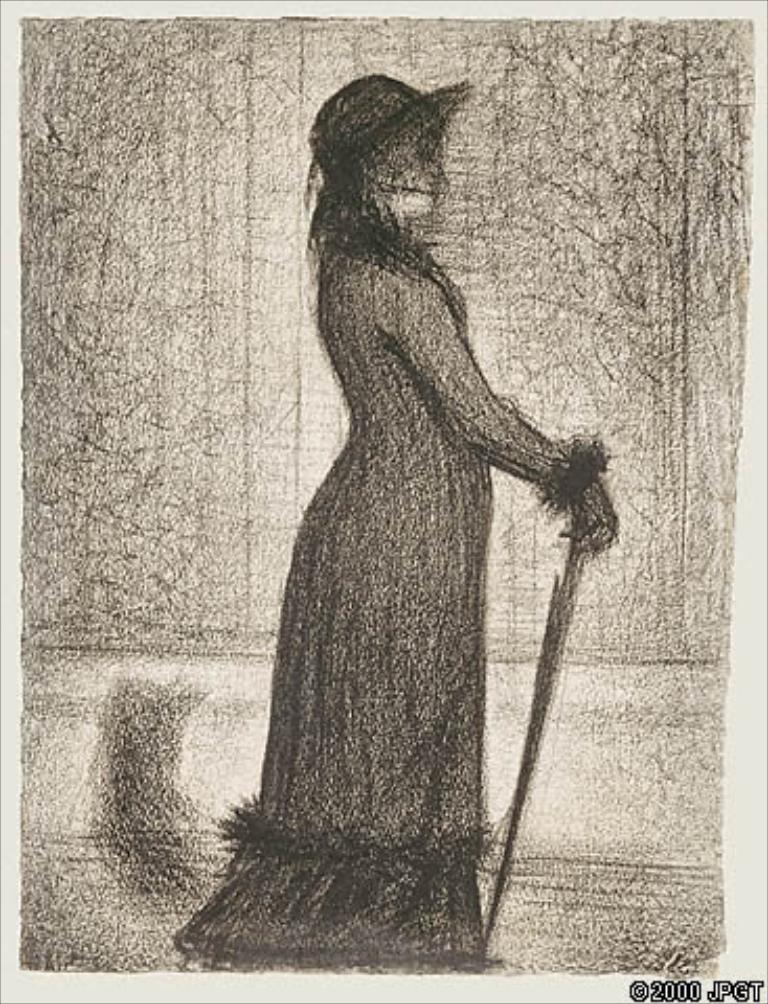What is the main subject of the image? There is an art piece in the image. Can you describe any additional features of the image? There is a watermark at the bottom of the image. What type of tray is being used to display the art piece in the image? There is no tray visible in the image; it only features an art piece and a watermark. 